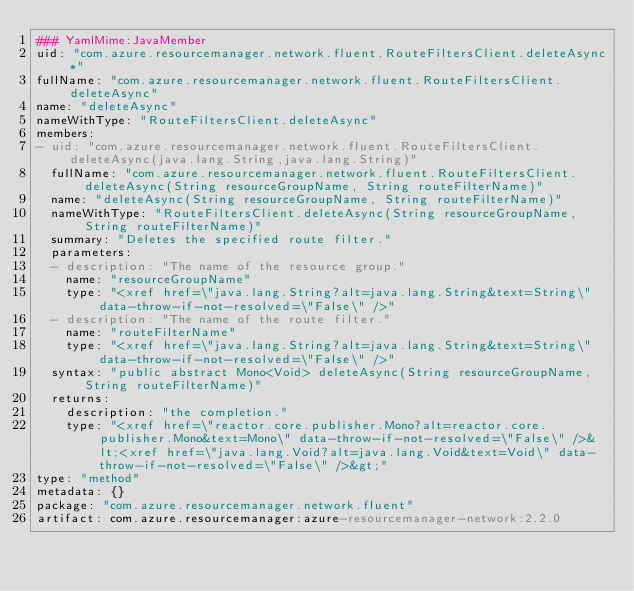<code> <loc_0><loc_0><loc_500><loc_500><_YAML_>### YamlMime:JavaMember
uid: "com.azure.resourcemanager.network.fluent.RouteFiltersClient.deleteAsync*"
fullName: "com.azure.resourcemanager.network.fluent.RouteFiltersClient.deleteAsync"
name: "deleteAsync"
nameWithType: "RouteFiltersClient.deleteAsync"
members:
- uid: "com.azure.resourcemanager.network.fluent.RouteFiltersClient.deleteAsync(java.lang.String,java.lang.String)"
  fullName: "com.azure.resourcemanager.network.fluent.RouteFiltersClient.deleteAsync(String resourceGroupName, String routeFilterName)"
  name: "deleteAsync(String resourceGroupName, String routeFilterName)"
  nameWithType: "RouteFiltersClient.deleteAsync(String resourceGroupName, String routeFilterName)"
  summary: "Deletes the specified route filter."
  parameters:
  - description: "The name of the resource group."
    name: "resourceGroupName"
    type: "<xref href=\"java.lang.String?alt=java.lang.String&text=String\" data-throw-if-not-resolved=\"False\" />"
  - description: "The name of the route filter."
    name: "routeFilterName"
    type: "<xref href=\"java.lang.String?alt=java.lang.String&text=String\" data-throw-if-not-resolved=\"False\" />"
  syntax: "public abstract Mono<Void> deleteAsync(String resourceGroupName, String routeFilterName)"
  returns:
    description: "the completion."
    type: "<xref href=\"reactor.core.publisher.Mono?alt=reactor.core.publisher.Mono&text=Mono\" data-throw-if-not-resolved=\"False\" />&lt;<xref href=\"java.lang.Void?alt=java.lang.Void&text=Void\" data-throw-if-not-resolved=\"False\" />&gt;"
type: "method"
metadata: {}
package: "com.azure.resourcemanager.network.fluent"
artifact: com.azure.resourcemanager:azure-resourcemanager-network:2.2.0
</code> 